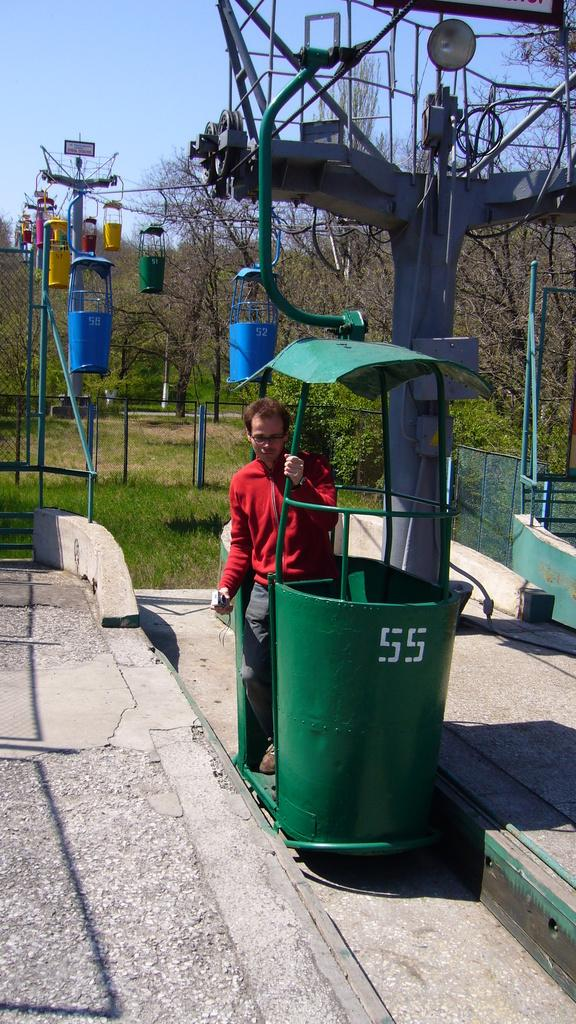<image>
Share a concise interpretation of the image provided. The green garbage can has the number 55 on it 